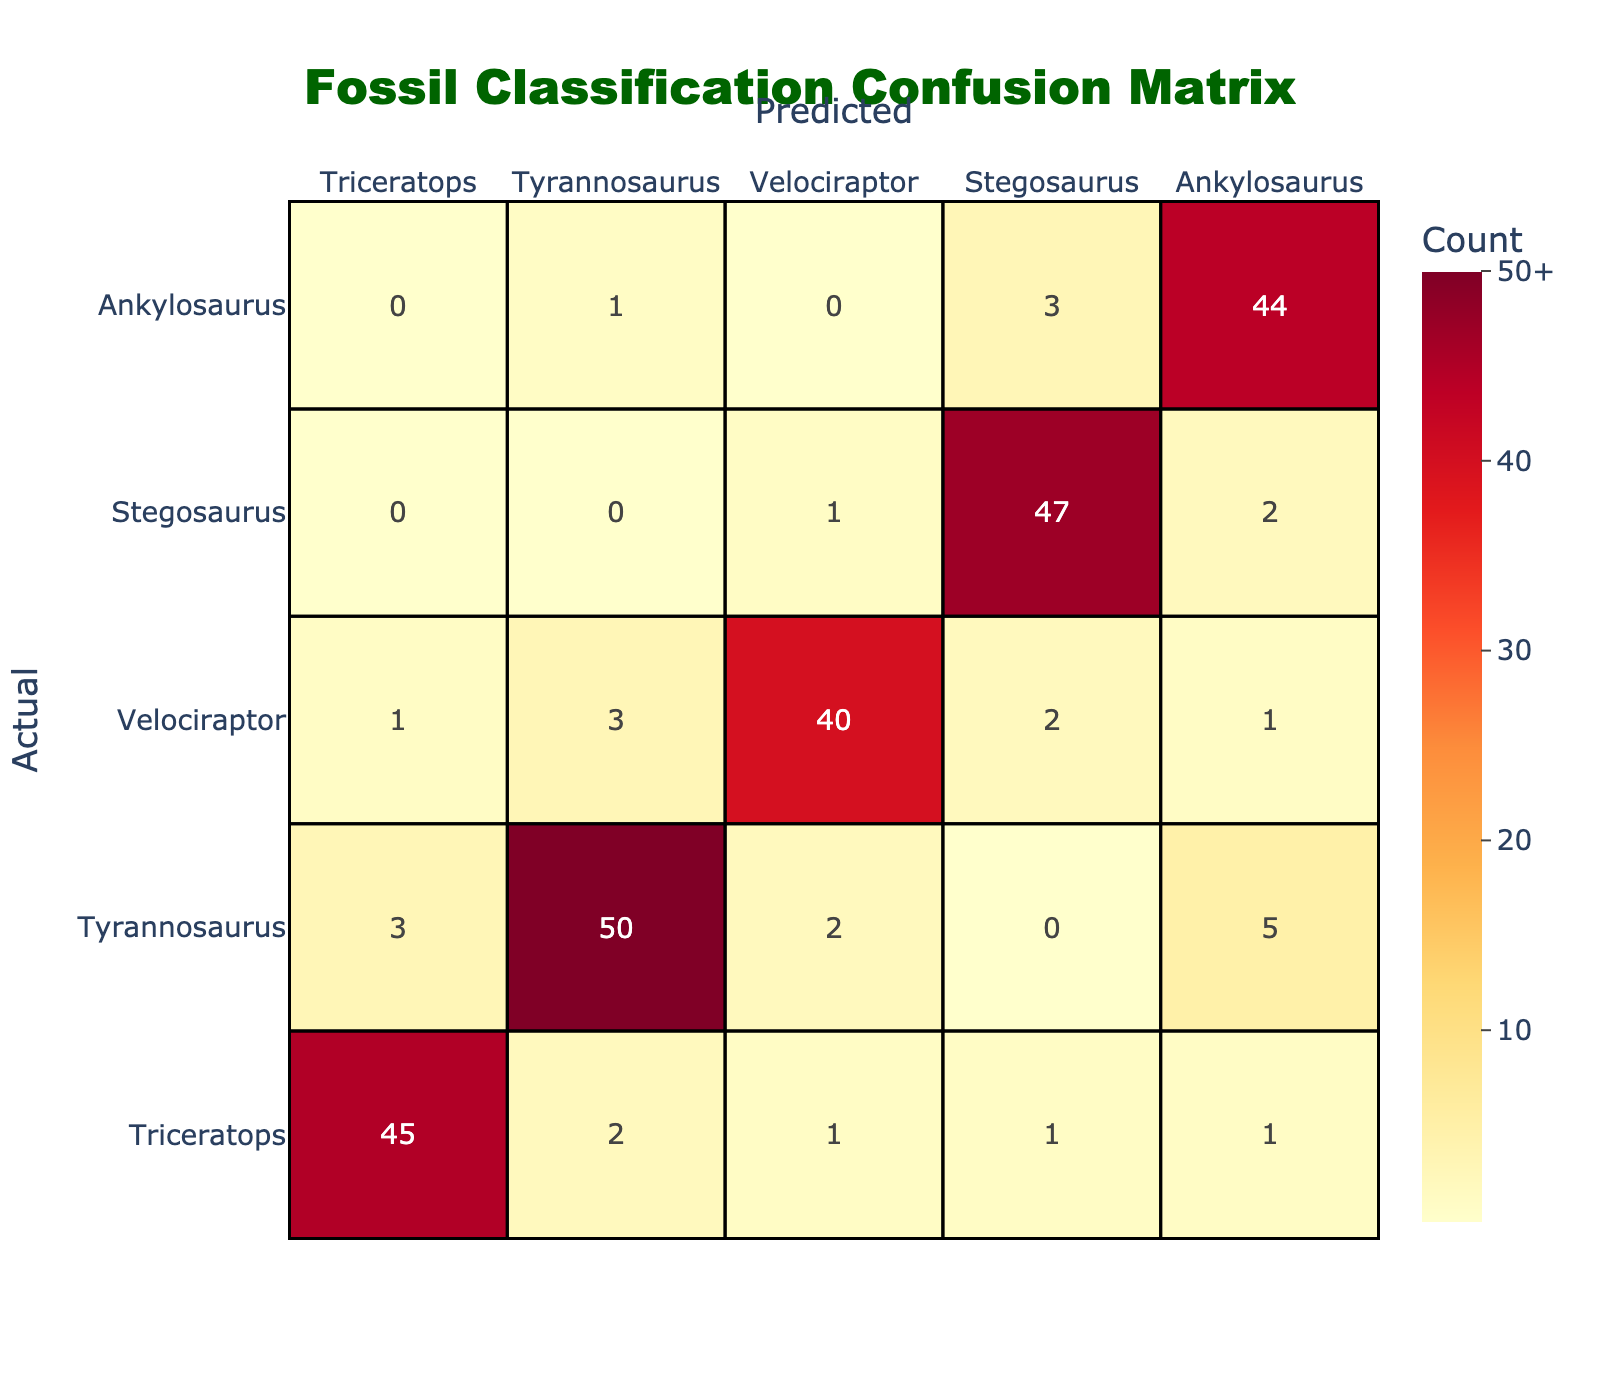What is the predicted count for Triceratops classified as Tyrannosaurus? In the row for Triceratops under the column Tyrannosaurus, the count is 2.
Answer: 2 What is the count of actual Velociraptor classified correctly as Velociraptor? In the row for Velociraptor, the diagonal entry for Velociraptor is 40, indicating the correct classifications.
Answer: 40 How many Tyrannosaurus samples were predicted to be Triceratops? In the row for Tyrannosaurus and the column for Triceratops, the count is 3, representing the misclassification.
Answer: 3 What is the total number of Stegosaurus samples? To find the total, sum the values in the Stegosaurus row: 0 (predicted as Triceratops) + 0 (Tyrannosaurus) + 1 (Velociraptor) + 47 (correct Stegosaurus) + 2 (predicted as Ankylosaurus), which equals 50.
Answer: 50 Are there more predicted samples for Triceratops than for Velociraptor? The predicted samples for Triceratops sum to 52 (45 + 3 + 1 + 0 + 0) while Velociraptor sums to 47 (1 + 2 + 40 + 1 + 3), indicating Triceratops has more.
Answer: Yes What is the difference between the correctly predicted Tyrannosaurus and the incorrectly predicted Ankylosaurus for Tyrannosaurus? The correctly predicted Tyrannosaurus count is 50, and the incorrectly predicted Ankylosaurus count is 5. The difference is 50 - 5 = 45.
Answer: 45 What percentage of Velociraptor samples were correctly recognized? The total Velociraptor predictions are 47 and correctly classified samples are 40. The percentage is (40/47) * 100, which rounds to approximately 85.11%.
Answer: 85.11% What is the average misclassification count for Ankylosaurus? The misclassifications for Ankylosaurus are from Triceratops (0), Tyrannosaurus (1), Velociraptor (0), and Stegosaurus (3), summing to 4. To find the average, we divide this by 4, the number of categories: 4/4 = 1.
Answer: 1 Is the total number of predicted samples for Velociraptor greater than for Stegosaurus? The total predictions for Velociraptor count to 47 (1 + 3 + 40 + 2 + 1), while for Stegosaurus, it is 50 (0 + 0 + 1 + 47 + 2). Since 47 is less than 50, the statement is false.
Answer: No 